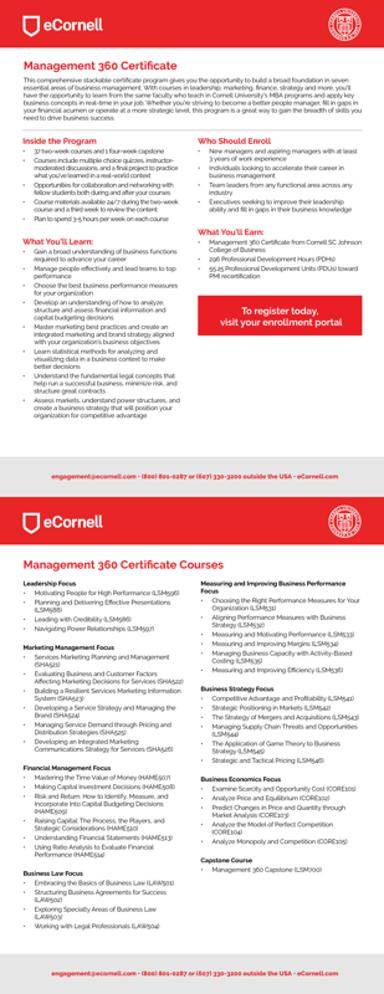What are some of the courses mentioned in the image? The image lists several courses included in the eCornell Management 360 Certificate, such as 'Leadership Focus,' 'Marketing Planning and Management,' 'Financial Management Focus,' and 'Business Law Focus.' Each course is tailored to boost specific managerial capabilities and business acumen. 